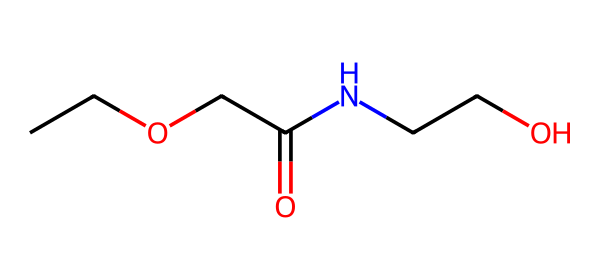what is the molecular formula of the compound? The SMILES representation can be translated to its molecular formula by identifying and counting the types and quantities of atoms present in the structure. This compound has 6 carbon (C), 13 hydrogen (H), 2 oxygen (O), and 1 nitrogen (N) atom.
Answer: C6H13N2O2 how many functional groups are present in the structure? By analyzing the SMILES, we can identify the functional groups. There is an amide group (due to the presence of the nitrogen atom next to a carbonyl) and ether linkages (indicated by the presence of the C-O-C bonds). Thus, there are 2 functional groups in total.
Answer: 2 what type of chemical is this compound classified as? The structure includes features of both ethers and amides, but due to the significant ether part of the molecule, it is primarily classified as an ether.
Answer: ether how many total bonds are present in the compound? To determine the total number of bonds, we count the single and double bonds in the chemical structure. The ether and amide groups contribute multiple sigma and one pi bond (double bond). Upon counting, there are 12 total bonds in the structure.
Answer: 12 what property of this compound makes it suitable for preservation? The presence of polar functional groups and ether linkages enhances solubility and stability, which are key properties for efficacy in preservation solutions.
Answer: solubility is this compound likely to be volatile at room temperature? The structure contains an ether, and ethers tend to have relatively low boiling points and can be somewhat volatile at room temperature due to their molecular weight and composition.
Answer: yes 